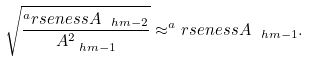<formula> <loc_0><loc_0><loc_500><loc_500>\sqrt { \frac { ^ { a } r s e n e s s A _ { \ h m - 2 } } { A _ { \ h m - 1 } ^ { 2 } } } \approx ^ { a } r s e n e s s A _ { \ h m - 1 } .</formula> 